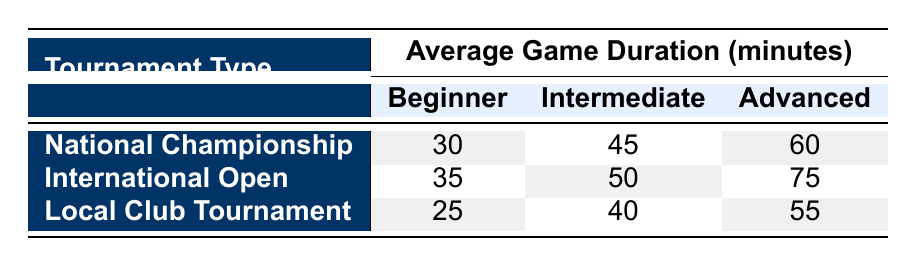What is the average game duration for beginners in the National Championship? The table shows the average game duration for beginners in the National Championship is 30 minutes.
Answer: 30 minutes Which tournament type has the longest average game duration for intermediates? The table shows the average game duration for intermediates in the International Open is 50 minutes, compared to 45 minutes in the National Championship and 40 minutes in the Local Club Tournament. Therefore, the International Open has the longest average game duration for intermediates.
Answer: International Open True or False: The average game duration for advanced players in the National Championship is less than that of the International Open. The average game duration for advanced players in the National Championship is 60 minutes, while in the International Open, it is 75 minutes. Thus, it is true that the duration in the National Championship is less than that in the International Open.
Answer: True What is the difference in average game duration for beginners versus advanced players in the Local Club Tournament? The average game duration for beginners in the Local Club Tournament is 25 minutes and for advanced players is 55 minutes. The difference is 55 - 25 = 30 minutes.
Answer: 30 minutes Which skill level has the least average game duration across all tournament types? Analyzing the table, we see that the average game duration for beginners is 30 (National Championship), 35 (International Open), and 25 (Local Club Tournament). The minimum is 25 minutes for beginners in the Local Club Tournament, making it the least.
Answer: Beginner What is the average game duration for advanced players in all tournament types? To find the average for advanced players, we sum the durations: 60 (National Championship) + 75 (International Open) + 55 (Local Club Tournament) = 190 minutes. Then, we divide by 3 (the number of tournaments), which gives us 190 / 3 ≈ 63.33 minutes.
Answer: 63.33 minutes Is the average game duration for intermediates in the National Championship greater than that for beginners in the Local Club Tournament? The average game duration for intermediates in the National Championship is 45 minutes, while for beginners in the Local Club Tournament, it is 25 minutes. Since 45 > 25, the statement is true.
Answer: True What is the total average game duration for beginners across all tournament types? The average game duration for beginners is 30 (National Championship) + 35 (International Open) + 25 (Local Club Tournament) = 90 minutes.
Answer: 90 minutes 